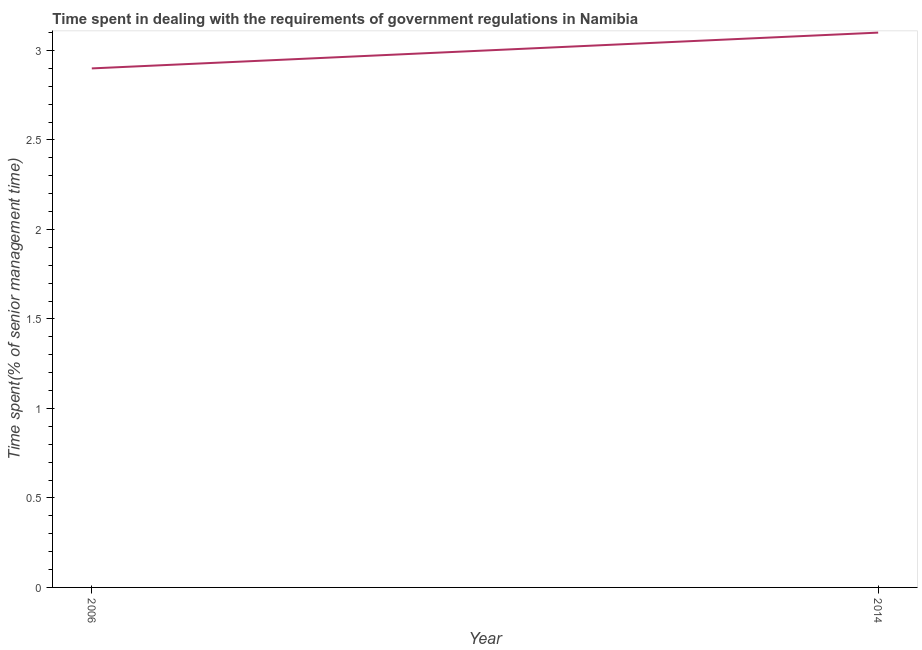What is the time spent in dealing with government regulations in 2014?
Ensure brevity in your answer.  3.1. Across all years, what is the minimum time spent in dealing with government regulations?
Your answer should be compact. 2.9. What is the difference between the time spent in dealing with government regulations in 2006 and 2014?
Your answer should be very brief. -0.2. What is the average time spent in dealing with government regulations per year?
Make the answer very short. 3. In how many years, is the time spent in dealing with government regulations greater than 2.2 %?
Provide a short and direct response. 2. Do a majority of the years between 2006 and 2014 (inclusive) have time spent in dealing with government regulations greater than 2.7 %?
Offer a terse response. Yes. What is the ratio of the time spent in dealing with government regulations in 2006 to that in 2014?
Provide a succinct answer. 0.94. Is the time spent in dealing with government regulations in 2006 less than that in 2014?
Provide a succinct answer. Yes. In how many years, is the time spent in dealing with government regulations greater than the average time spent in dealing with government regulations taken over all years?
Give a very brief answer. 1. How many lines are there?
Keep it short and to the point. 1. What is the difference between two consecutive major ticks on the Y-axis?
Offer a terse response. 0.5. Are the values on the major ticks of Y-axis written in scientific E-notation?
Provide a short and direct response. No. Does the graph contain grids?
Make the answer very short. No. What is the title of the graph?
Give a very brief answer. Time spent in dealing with the requirements of government regulations in Namibia. What is the label or title of the X-axis?
Your answer should be very brief. Year. What is the label or title of the Y-axis?
Your answer should be very brief. Time spent(% of senior management time). What is the Time spent(% of senior management time) in 2006?
Offer a terse response. 2.9. What is the Time spent(% of senior management time) of 2014?
Ensure brevity in your answer.  3.1. What is the difference between the Time spent(% of senior management time) in 2006 and 2014?
Give a very brief answer. -0.2. What is the ratio of the Time spent(% of senior management time) in 2006 to that in 2014?
Make the answer very short. 0.94. 